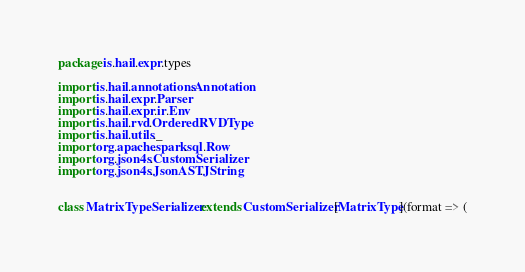<code> <loc_0><loc_0><loc_500><loc_500><_Scala_>package is.hail.expr.types

import is.hail.annotations.Annotation
import is.hail.expr.Parser
import is.hail.expr.ir.Env
import is.hail.rvd.OrderedRVDType
import is.hail.utils._
import org.apache.spark.sql.Row
import org.json4s.CustomSerializer
import org.json4s.JsonAST.JString


class MatrixTypeSerializer extends CustomSerializer[MatrixType](format => (</code> 